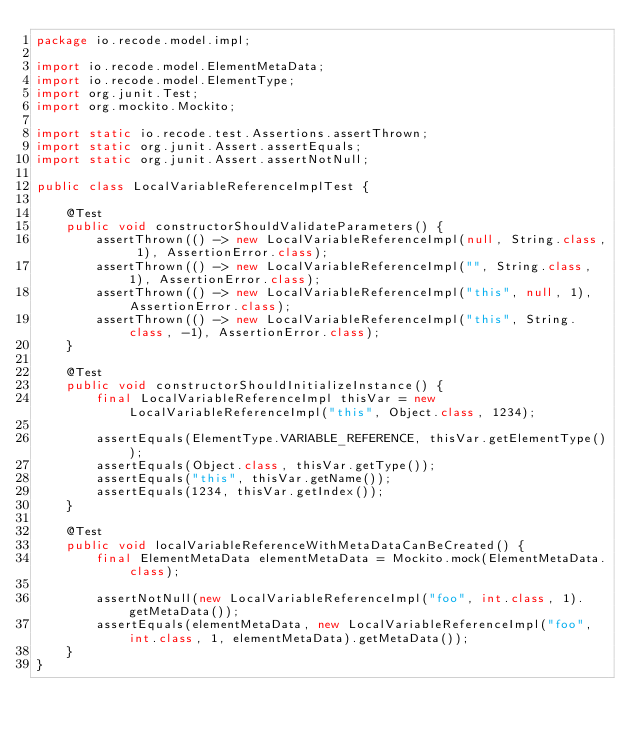<code> <loc_0><loc_0><loc_500><loc_500><_Java_>package io.recode.model.impl;

import io.recode.model.ElementMetaData;
import io.recode.model.ElementType;
import org.junit.Test;
import org.mockito.Mockito;

import static io.recode.test.Assertions.assertThrown;
import static org.junit.Assert.assertEquals;
import static org.junit.Assert.assertNotNull;

public class LocalVariableReferenceImplTest {

    @Test
    public void constructorShouldValidateParameters() {
        assertThrown(() -> new LocalVariableReferenceImpl(null, String.class, 1), AssertionError.class);
        assertThrown(() -> new LocalVariableReferenceImpl("", String.class, 1), AssertionError.class);
        assertThrown(() -> new LocalVariableReferenceImpl("this", null, 1), AssertionError.class);
        assertThrown(() -> new LocalVariableReferenceImpl("this", String.class, -1), AssertionError.class);
    }

    @Test
    public void constructorShouldInitializeInstance() {
        final LocalVariableReferenceImpl thisVar = new LocalVariableReferenceImpl("this", Object.class, 1234);

        assertEquals(ElementType.VARIABLE_REFERENCE, thisVar.getElementType());
        assertEquals(Object.class, thisVar.getType());
        assertEquals("this", thisVar.getName());
        assertEquals(1234, thisVar.getIndex());
    }

    @Test
    public void localVariableReferenceWithMetaDataCanBeCreated() {
        final ElementMetaData elementMetaData = Mockito.mock(ElementMetaData.class);

        assertNotNull(new LocalVariableReferenceImpl("foo", int.class, 1).getMetaData());
        assertEquals(elementMetaData, new LocalVariableReferenceImpl("foo", int.class, 1, elementMetaData).getMetaData());
    }
}
</code> 